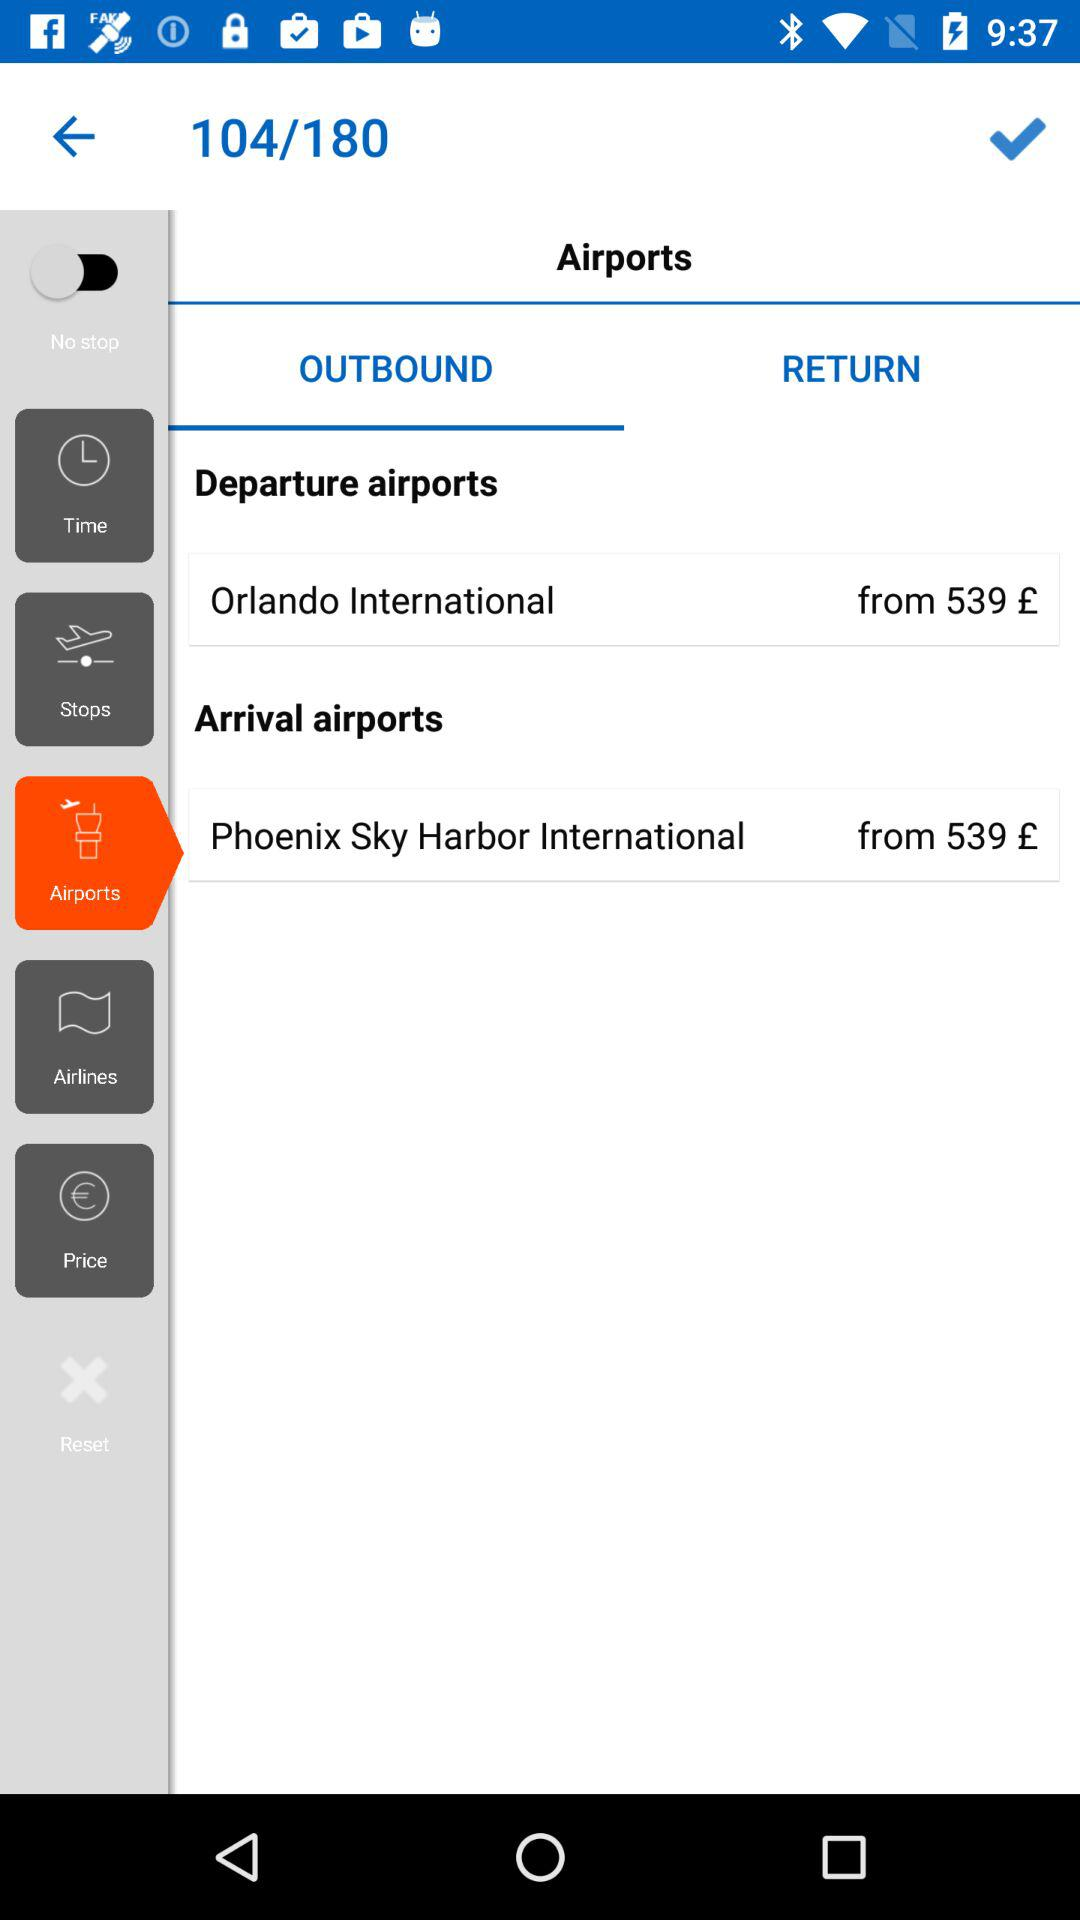What is the status of "No stop"? The status is "off". 